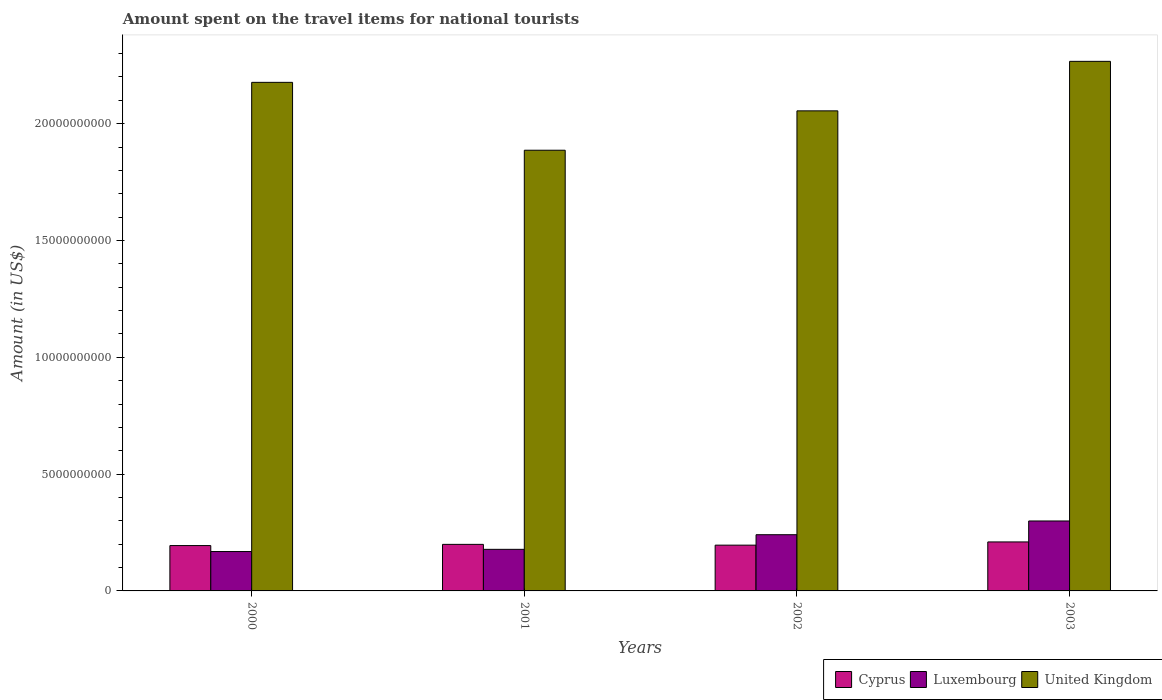How many bars are there on the 3rd tick from the right?
Offer a very short reply. 3. In how many cases, is the number of bars for a given year not equal to the number of legend labels?
Provide a succinct answer. 0. What is the amount spent on the travel items for national tourists in United Kingdom in 2002?
Provide a short and direct response. 2.05e+1. Across all years, what is the maximum amount spent on the travel items for national tourists in Cyprus?
Ensure brevity in your answer.  2.10e+09. Across all years, what is the minimum amount spent on the travel items for national tourists in Cyprus?
Your answer should be compact. 1.94e+09. In which year was the amount spent on the travel items for national tourists in United Kingdom maximum?
Your answer should be compact. 2003. In which year was the amount spent on the travel items for national tourists in United Kingdom minimum?
Provide a short and direct response. 2001. What is the total amount spent on the travel items for national tourists in Cyprus in the graph?
Offer a terse response. 7.99e+09. What is the difference between the amount spent on the travel items for national tourists in United Kingdom in 2000 and that in 2003?
Your response must be concise. -8.99e+08. What is the difference between the amount spent on the travel items for national tourists in Luxembourg in 2003 and the amount spent on the travel items for national tourists in United Kingdom in 2002?
Offer a terse response. -1.76e+1. What is the average amount spent on the travel items for national tourists in Cyprus per year?
Offer a very short reply. 2.00e+09. In the year 2000, what is the difference between the amount spent on the travel items for national tourists in Cyprus and amount spent on the travel items for national tourists in United Kingdom?
Make the answer very short. -1.98e+1. What is the ratio of the amount spent on the travel items for national tourists in Cyprus in 2000 to that in 2002?
Offer a very short reply. 0.99. What is the difference between the highest and the second highest amount spent on the travel items for national tourists in Luxembourg?
Offer a very short reply. 5.88e+08. What is the difference between the highest and the lowest amount spent on the travel items for national tourists in Luxembourg?
Provide a succinct answer. 1.31e+09. In how many years, is the amount spent on the travel items for national tourists in Cyprus greater than the average amount spent on the travel items for national tourists in Cyprus taken over all years?
Your answer should be very brief. 1. What does the 3rd bar from the left in 2003 represents?
Provide a short and direct response. United Kingdom. What does the 1st bar from the right in 2002 represents?
Provide a short and direct response. United Kingdom. How many bars are there?
Offer a terse response. 12. Does the graph contain any zero values?
Keep it short and to the point. No. Where does the legend appear in the graph?
Offer a terse response. Bottom right. How many legend labels are there?
Offer a terse response. 3. How are the legend labels stacked?
Your answer should be compact. Horizontal. What is the title of the graph?
Provide a short and direct response. Amount spent on the travel items for national tourists. Does "New Zealand" appear as one of the legend labels in the graph?
Provide a succinct answer. No. What is the label or title of the X-axis?
Offer a very short reply. Years. What is the Amount (in US$) of Cyprus in 2000?
Your answer should be very brief. 1.94e+09. What is the Amount (in US$) of Luxembourg in 2000?
Provide a succinct answer. 1.69e+09. What is the Amount (in US$) in United Kingdom in 2000?
Give a very brief answer. 2.18e+1. What is the Amount (in US$) of Cyprus in 2001?
Ensure brevity in your answer.  1.99e+09. What is the Amount (in US$) of Luxembourg in 2001?
Provide a succinct answer. 1.78e+09. What is the Amount (in US$) in United Kingdom in 2001?
Provide a short and direct response. 1.89e+1. What is the Amount (in US$) in Cyprus in 2002?
Your response must be concise. 1.96e+09. What is the Amount (in US$) in Luxembourg in 2002?
Keep it short and to the point. 2.41e+09. What is the Amount (in US$) of United Kingdom in 2002?
Your answer should be compact. 2.05e+1. What is the Amount (in US$) in Cyprus in 2003?
Your answer should be very brief. 2.10e+09. What is the Amount (in US$) in Luxembourg in 2003?
Give a very brief answer. 2.99e+09. What is the Amount (in US$) in United Kingdom in 2003?
Ensure brevity in your answer.  2.27e+1. Across all years, what is the maximum Amount (in US$) of Cyprus?
Make the answer very short. 2.10e+09. Across all years, what is the maximum Amount (in US$) of Luxembourg?
Provide a short and direct response. 2.99e+09. Across all years, what is the maximum Amount (in US$) in United Kingdom?
Offer a terse response. 2.27e+1. Across all years, what is the minimum Amount (in US$) of Cyprus?
Offer a very short reply. 1.94e+09. Across all years, what is the minimum Amount (in US$) of Luxembourg?
Give a very brief answer. 1.69e+09. Across all years, what is the minimum Amount (in US$) of United Kingdom?
Offer a terse response. 1.89e+1. What is the total Amount (in US$) of Cyprus in the graph?
Your answer should be compact. 7.99e+09. What is the total Amount (in US$) of Luxembourg in the graph?
Provide a succinct answer. 8.87e+09. What is the total Amount (in US$) of United Kingdom in the graph?
Ensure brevity in your answer.  8.38e+1. What is the difference between the Amount (in US$) of Cyprus in 2000 and that in 2001?
Make the answer very short. -5.20e+07. What is the difference between the Amount (in US$) of Luxembourg in 2000 and that in 2001?
Make the answer very short. -9.40e+07. What is the difference between the Amount (in US$) in United Kingdom in 2000 and that in 2001?
Give a very brief answer. 2.90e+09. What is the difference between the Amount (in US$) in Cyprus in 2000 and that in 2002?
Offer a terse response. -1.80e+07. What is the difference between the Amount (in US$) in Luxembourg in 2000 and that in 2002?
Your answer should be compact. -7.20e+08. What is the difference between the Amount (in US$) of United Kingdom in 2000 and that in 2002?
Provide a succinct answer. 1.22e+09. What is the difference between the Amount (in US$) in Cyprus in 2000 and that in 2003?
Ensure brevity in your answer.  -1.56e+08. What is the difference between the Amount (in US$) in Luxembourg in 2000 and that in 2003?
Provide a short and direct response. -1.31e+09. What is the difference between the Amount (in US$) of United Kingdom in 2000 and that in 2003?
Keep it short and to the point. -8.99e+08. What is the difference between the Amount (in US$) in Cyprus in 2001 and that in 2002?
Your answer should be compact. 3.40e+07. What is the difference between the Amount (in US$) of Luxembourg in 2001 and that in 2002?
Your answer should be compact. -6.26e+08. What is the difference between the Amount (in US$) in United Kingdom in 2001 and that in 2002?
Provide a short and direct response. -1.68e+09. What is the difference between the Amount (in US$) in Cyprus in 2001 and that in 2003?
Your answer should be very brief. -1.04e+08. What is the difference between the Amount (in US$) in Luxembourg in 2001 and that in 2003?
Keep it short and to the point. -1.21e+09. What is the difference between the Amount (in US$) of United Kingdom in 2001 and that in 2003?
Make the answer very short. -3.80e+09. What is the difference between the Amount (in US$) of Cyprus in 2002 and that in 2003?
Make the answer very short. -1.38e+08. What is the difference between the Amount (in US$) in Luxembourg in 2002 and that in 2003?
Provide a short and direct response. -5.88e+08. What is the difference between the Amount (in US$) in United Kingdom in 2002 and that in 2003?
Your answer should be compact. -2.12e+09. What is the difference between the Amount (in US$) in Cyprus in 2000 and the Amount (in US$) in Luxembourg in 2001?
Provide a short and direct response. 1.61e+08. What is the difference between the Amount (in US$) of Cyprus in 2000 and the Amount (in US$) of United Kingdom in 2001?
Give a very brief answer. -1.69e+1. What is the difference between the Amount (in US$) of Luxembourg in 2000 and the Amount (in US$) of United Kingdom in 2001?
Offer a terse response. -1.72e+1. What is the difference between the Amount (in US$) of Cyprus in 2000 and the Amount (in US$) of Luxembourg in 2002?
Keep it short and to the point. -4.65e+08. What is the difference between the Amount (in US$) of Cyprus in 2000 and the Amount (in US$) of United Kingdom in 2002?
Your response must be concise. -1.86e+1. What is the difference between the Amount (in US$) of Luxembourg in 2000 and the Amount (in US$) of United Kingdom in 2002?
Offer a very short reply. -1.89e+1. What is the difference between the Amount (in US$) of Cyprus in 2000 and the Amount (in US$) of Luxembourg in 2003?
Offer a terse response. -1.05e+09. What is the difference between the Amount (in US$) of Cyprus in 2000 and the Amount (in US$) of United Kingdom in 2003?
Offer a terse response. -2.07e+1. What is the difference between the Amount (in US$) in Luxembourg in 2000 and the Amount (in US$) in United Kingdom in 2003?
Give a very brief answer. -2.10e+1. What is the difference between the Amount (in US$) in Cyprus in 2001 and the Amount (in US$) in Luxembourg in 2002?
Your response must be concise. -4.13e+08. What is the difference between the Amount (in US$) of Cyprus in 2001 and the Amount (in US$) of United Kingdom in 2002?
Ensure brevity in your answer.  -1.86e+1. What is the difference between the Amount (in US$) of Luxembourg in 2001 and the Amount (in US$) of United Kingdom in 2002?
Your response must be concise. -1.88e+1. What is the difference between the Amount (in US$) in Cyprus in 2001 and the Amount (in US$) in Luxembourg in 2003?
Keep it short and to the point. -1.00e+09. What is the difference between the Amount (in US$) in Cyprus in 2001 and the Amount (in US$) in United Kingdom in 2003?
Provide a succinct answer. -2.07e+1. What is the difference between the Amount (in US$) in Luxembourg in 2001 and the Amount (in US$) in United Kingdom in 2003?
Offer a terse response. -2.09e+1. What is the difference between the Amount (in US$) of Cyprus in 2002 and the Amount (in US$) of Luxembourg in 2003?
Provide a succinct answer. -1.04e+09. What is the difference between the Amount (in US$) of Cyprus in 2002 and the Amount (in US$) of United Kingdom in 2003?
Make the answer very short. -2.07e+1. What is the difference between the Amount (in US$) in Luxembourg in 2002 and the Amount (in US$) in United Kingdom in 2003?
Provide a succinct answer. -2.03e+1. What is the average Amount (in US$) of Cyprus per year?
Give a very brief answer. 2.00e+09. What is the average Amount (in US$) of Luxembourg per year?
Your answer should be compact. 2.22e+09. What is the average Amount (in US$) of United Kingdom per year?
Provide a short and direct response. 2.10e+1. In the year 2000, what is the difference between the Amount (in US$) in Cyprus and Amount (in US$) in Luxembourg?
Provide a short and direct response. 2.55e+08. In the year 2000, what is the difference between the Amount (in US$) in Cyprus and Amount (in US$) in United Kingdom?
Your response must be concise. -1.98e+1. In the year 2000, what is the difference between the Amount (in US$) in Luxembourg and Amount (in US$) in United Kingdom?
Offer a terse response. -2.01e+1. In the year 2001, what is the difference between the Amount (in US$) in Cyprus and Amount (in US$) in Luxembourg?
Provide a succinct answer. 2.13e+08. In the year 2001, what is the difference between the Amount (in US$) in Cyprus and Amount (in US$) in United Kingdom?
Provide a short and direct response. -1.69e+1. In the year 2001, what is the difference between the Amount (in US$) of Luxembourg and Amount (in US$) of United Kingdom?
Ensure brevity in your answer.  -1.71e+1. In the year 2002, what is the difference between the Amount (in US$) of Cyprus and Amount (in US$) of Luxembourg?
Your answer should be compact. -4.47e+08. In the year 2002, what is the difference between the Amount (in US$) of Cyprus and Amount (in US$) of United Kingdom?
Offer a terse response. -1.86e+1. In the year 2002, what is the difference between the Amount (in US$) of Luxembourg and Amount (in US$) of United Kingdom?
Your answer should be compact. -1.81e+1. In the year 2003, what is the difference between the Amount (in US$) of Cyprus and Amount (in US$) of Luxembourg?
Make the answer very short. -8.97e+08. In the year 2003, what is the difference between the Amount (in US$) in Cyprus and Amount (in US$) in United Kingdom?
Your answer should be very brief. -2.06e+1. In the year 2003, what is the difference between the Amount (in US$) of Luxembourg and Amount (in US$) of United Kingdom?
Your response must be concise. -1.97e+1. What is the ratio of the Amount (in US$) of Cyprus in 2000 to that in 2001?
Provide a short and direct response. 0.97. What is the ratio of the Amount (in US$) of Luxembourg in 2000 to that in 2001?
Offer a very short reply. 0.95. What is the ratio of the Amount (in US$) of United Kingdom in 2000 to that in 2001?
Provide a short and direct response. 1.15. What is the ratio of the Amount (in US$) of Cyprus in 2000 to that in 2002?
Ensure brevity in your answer.  0.99. What is the ratio of the Amount (in US$) of Luxembourg in 2000 to that in 2002?
Offer a very short reply. 0.7. What is the ratio of the Amount (in US$) of United Kingdom in 2000 to that in 2002?
Give a very brief answer. 1.06. What is the ratio of the Amount (in US$) in Cyprus in 2000 to that in 2003?
Offer a terse response. 0.93. What is the ratio of the Amount (in US$) in Luxembourg in 2000 to that in 2003?
Offer a terse response. 0.56. What is the ratio of the Amount (in US$) of United Kingdom in 2000 to that in 2003?
Provide a succinct answer. 0.96. What is the ratio of the Amount (in US$) of Cyprus in 2001 to that in 2002?
Make the answer very short. 1.02. What is the ratio of the Amount (in US$) of Luxembourg in 2001 to that in 2002?
Your answer should be compact. 0.74. What is the ratio of the Amount (in US$) of United Kingdom in 2001 to that in 2002?
Your answer should be compact. 0.92. What is the ratio of the Amount (in US$) of Cyprus in 2001 to that in 2003?
Provide a short and direct response. 0.95. What is the ratio of the Amount (in US$) of Luxembourg in 2001 to that in 2003?
Offer a very short reply. 0.59. What is the ratio of the Amount (in US$) in United Kingdom in 2001 to that in 2003?
Make the answer very short. 0.83. What is the ratio of the Amount (in US$) in Cyprus in 2002 to that in 2003?
Offer a terse response. 0.93. What is the ratio of the Amount (in US$) in Luxembourg in 2002 to that in 2003?
Your answer should be compact. 0.8. What is the ratio of the Amount (in US$) in United Kingdom in 2002 to that in 2003?
Your answer should be compact. 0.91. What is the difference between the highest and the second highest Amount (in US$) in Cyprus?
Provide a short and direct response. 1.04e+08. What is the difference between the highest and the second highest Amount (in US$) in Luxembourg?
Your answer should be very brief. 5.88e+08. What is the difference between the highest and the second highest Amount (in US$) of United Kingdom?
Offer a terse response. 8.99e+08. What is the difference between the highest and the lowest Amount (in US$) of Cyprus?
Offer a terse response. 1.56e+08. What is the difference between the highest and the lowest Amount (in US$) in Luxembourg?
Keep it short and to the point. 1.31e+09. What is the difference between the highest and the lowest Amount (in US$) of United Kingdom?
Provide a succinct answer. 3.80e+09. 